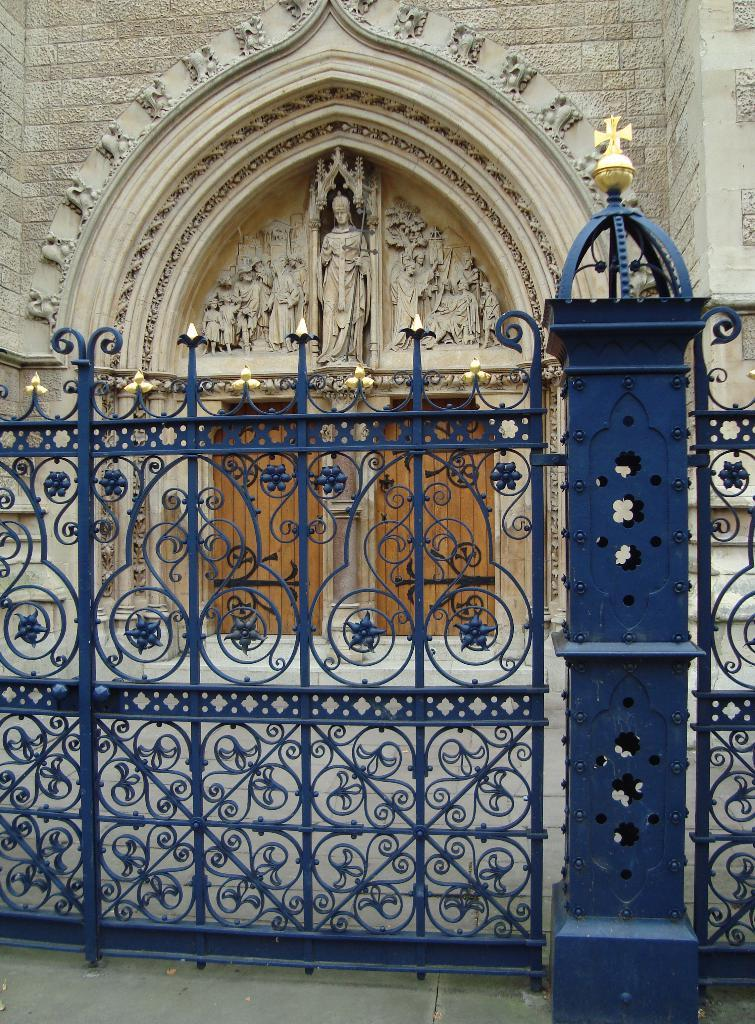What structure can be seen in the image? There is a gate in the image. What is located behind the gate? There is a church behind the gate. What type of jeans is the fog wearing in the image? There is no fog or jeans present in the image. What religious beliefs are depicted in the image? The image only shows a gate and a church, so it is not possible to determine the religious beliefs depicted. 